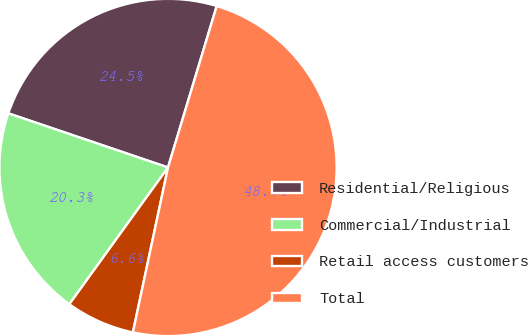<chart> <loc_0><loc_0><loc_500><loc_500><pie_chart><fcel>Residential/Religious<fcel>Commercial/Industrial<fcel>Retail access customers<fcel>Total<nl><fcel>24.46%<fcel>20.25%<fcel>6.61%<fcel>48.67%<nl></chart> 